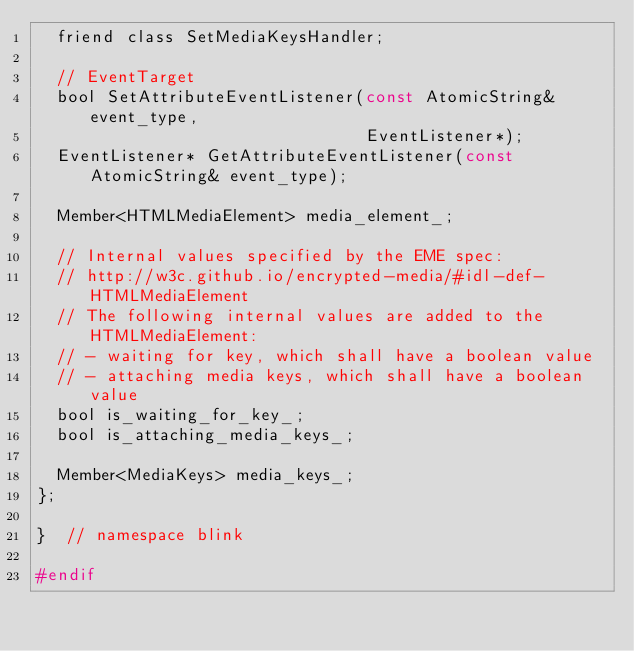<code> <loc_0><loc_0><loc_500><loc_500><_C_>  friend class SetMediaKeysHandler;

  // EventTarget
  bool SetAttributeEventListener(const AtomicString& event_type,
                                 EventListener*);
  EventListener* GetAttributeEventListener(const AtomicString& event_type);

  Member<HTMLMediaElement> media_element_;

  // Internal values specified by the EME spec:
  // http://w3c.github.io/encrypted-media/#idl-def-HTMLMediaElement
  // The following internal values are added to the HTMLMediaElement:
  // - waiting for key, which shall have a boolean value
  // - attaching media keys, which shall have a boolean value
  bool is_waiting_for_key_;
  bool is_attaching_media_keys_;

  Member<MediaKeys> media_keys_;
};

}  // namespace blink

#endif
</code> 